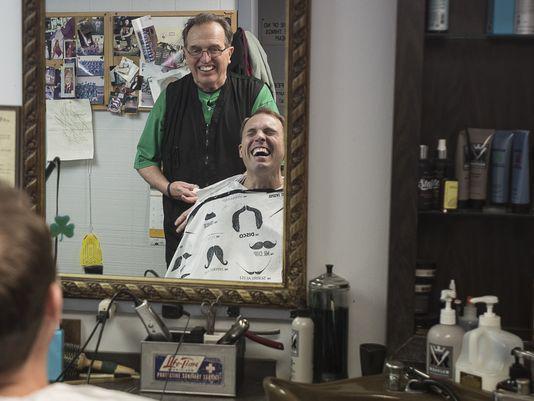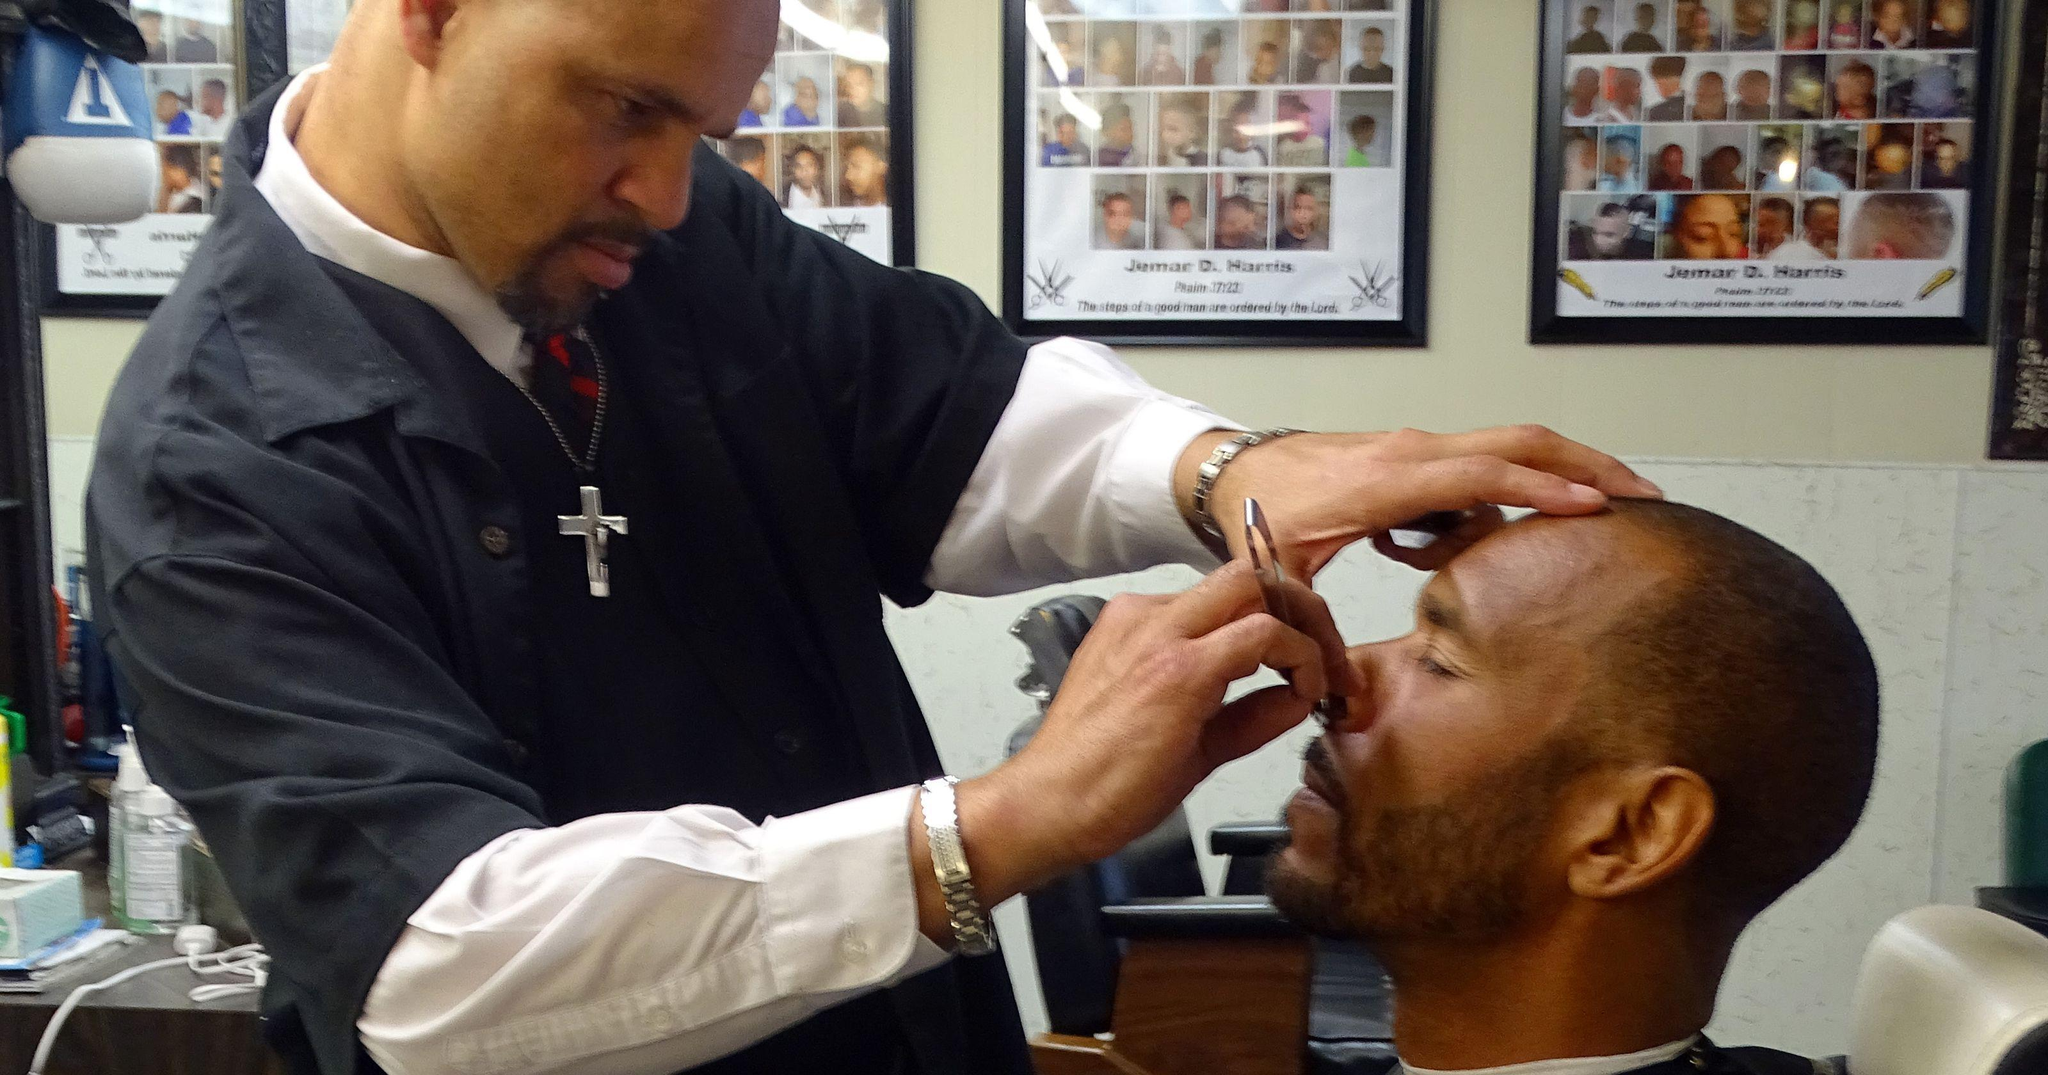The first image is the image on the left, the second image is the image on the right. Given the left and right images, does the statement "Exactly two men in the barber shop are clean shaven." hold true? Answer yes or no. Yes. The first image is the image on the left, the second image is the image on the right. Given the left and right images, does the statement "The left and right image contains a total of four men in a barber shop." hold true? Answer yes or no. Yes. 